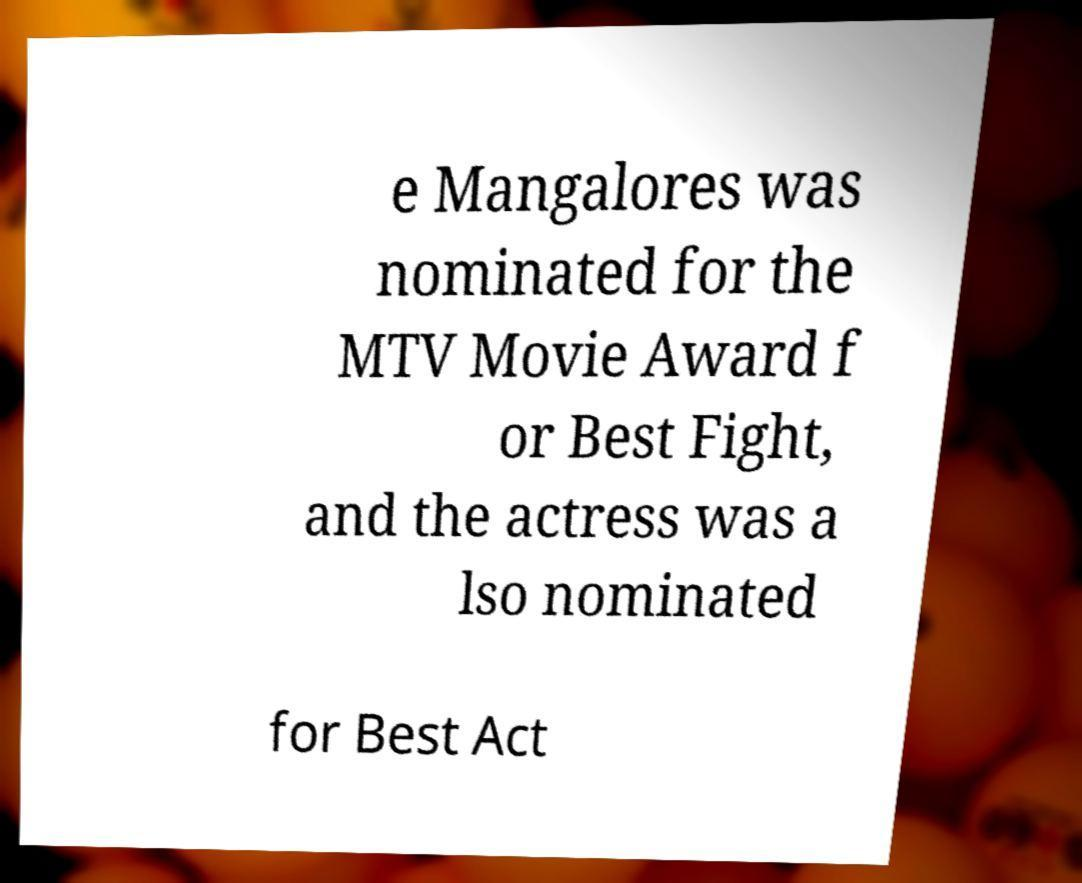Can you accurately transcribe the text from the provided image for me? e Mangalores was nominated for the MTV Movie Award f or Best Fight, and the actress was a lso nominated for Best Act 